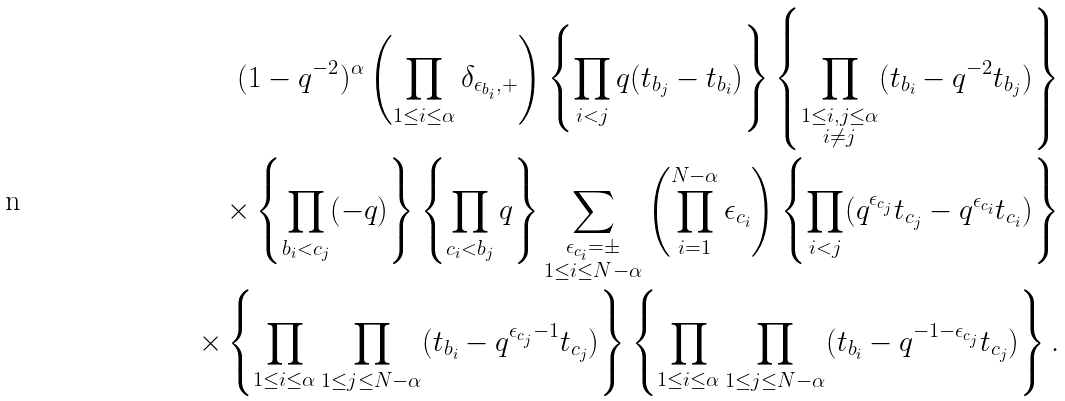<formula> <loc_0><loc_0><loc_500><loc_500>( 1 - q ^ { - 2 } ) ^ { \alpha } \left ( \prod _ { 1 \leq i \leq \alpha } \delta _ { \epsilon _ { b _ { i } } , + } \right ) \left \{ \prod _ { i < j } q ( t _ { b _ { j } } - t _ { b _ { i } } ) \right \} \left \{ \prod _ { \substack { 1 \leq i , j \leq \alpha \\ i \ne j } } ( t _ { b _ { i } } - q ^ { - 2 } t _ { b _ { j } } ) \right \} \\ \times \left \{ \prod _ { b _ { i } < c _ { j } } ( - q ) \right \} \left \{ \prod _ { c _ { i } < b _ { j } } q \right \} \sum _ { \substack { \epsilon _ { c _ { i } } = \pm \\ 1 \leq i \leq N - \alpha } } \left ( \prod _ { i = 1 } ^ { N - \alpha } \epsilon _ { c _ { i } } \right ) \left \{ \prod _ { i < j } ( q ^ { \epsilon _ { c _ { j } } } t _ { c _ { j } } - q ^ { \epsilon _ { c _ { i } } } t _ { c _ { i } } ) \right \} \\ \times \left \{ \prod _ { 1 \leq i \leq \alpha } \prod _ { 1 \leq j \leq N - \alpha } ( t _ { b _ { i } } - q ^ { \epsilon _ { c _ { j } } - 1 } t _ { c _ { j } } ) \right \} \left \{ \prod _ { 1 \leq i \leq \alpha } \prod _ { 1 \leq j \leq N - \alpha } ( t _ { b _ { i } } - q ^ { - 1 - \epsilon _ { c _ { j } } } t _ { c _ { j } } ) \right \} .</formula> 